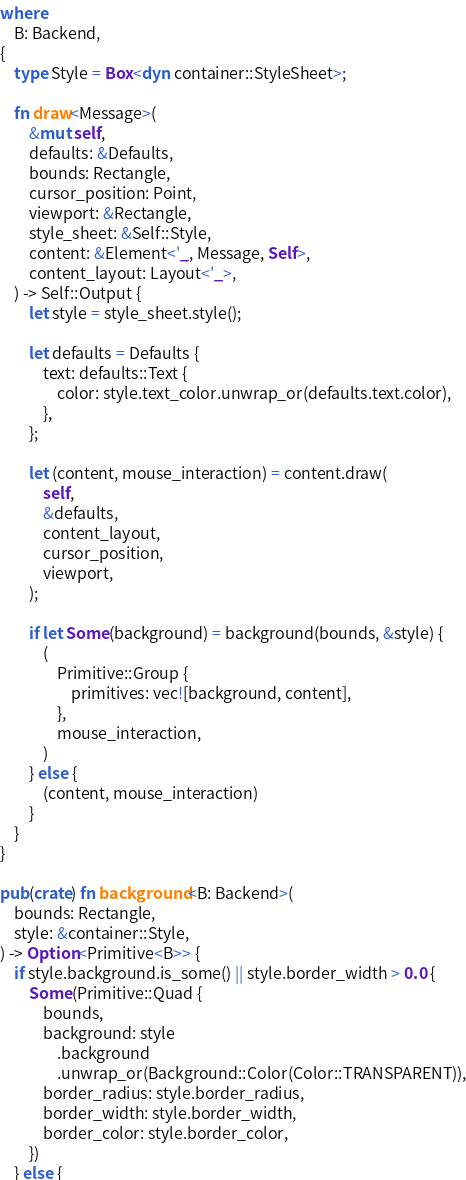Convert code to text. <code><loc_0><loc_0><loc_500><loc_500><_Rust_>where
    B: Backend,
{
    type Style = Box<dyn container::StyleSheet>;

    fn draw<Message>(
        &mut self,
        defaults: &Defaults,
        bounds: Rectangle,
        cursor_position: Point,
        viewport: &Rectangle,
        style_sheet: &Self::Style,
        content: &Element<'_, Message, Self>,
        content_layout: Layout<'_>,
    ) -> Self::Output {
        let style = style_sheet.style();

        let defaults = Defaults {
            text: defaults::Text {
                color: style.text_color.unwrap_or(defaults.text.color),
            },
        };

        let (content, mouse_interaction) = content.draw(
            self,
            &defaults,
            content_layout,
            cursor_position,
            viewport,
        );

        if let Some(background) = background(bounds, &style) {
            (
                Primitive::Group {
                    primitives: vec![background, content],
                },
                mouse_interaction,
            )
        } else {
            (content, mouse_interaction)
        }
    }
}

pub(crate) fn background<B: Backend>(
    bounds: Rectangle,
    style: &container::Style,
) -> Option<Primitive<B>> {
    if style.background.is_some() || style.border_width > 0.0 {
        Some(Primitive::Quad {
            bounds,
            background: style
                .background
                .unwrap_or(Background::Color(Color::TRANSPARENT)),
            border_radius: style.border_radius,
            border_width: style.border_width,
            border_color: style.border_color,
        })
    } else {</code> 